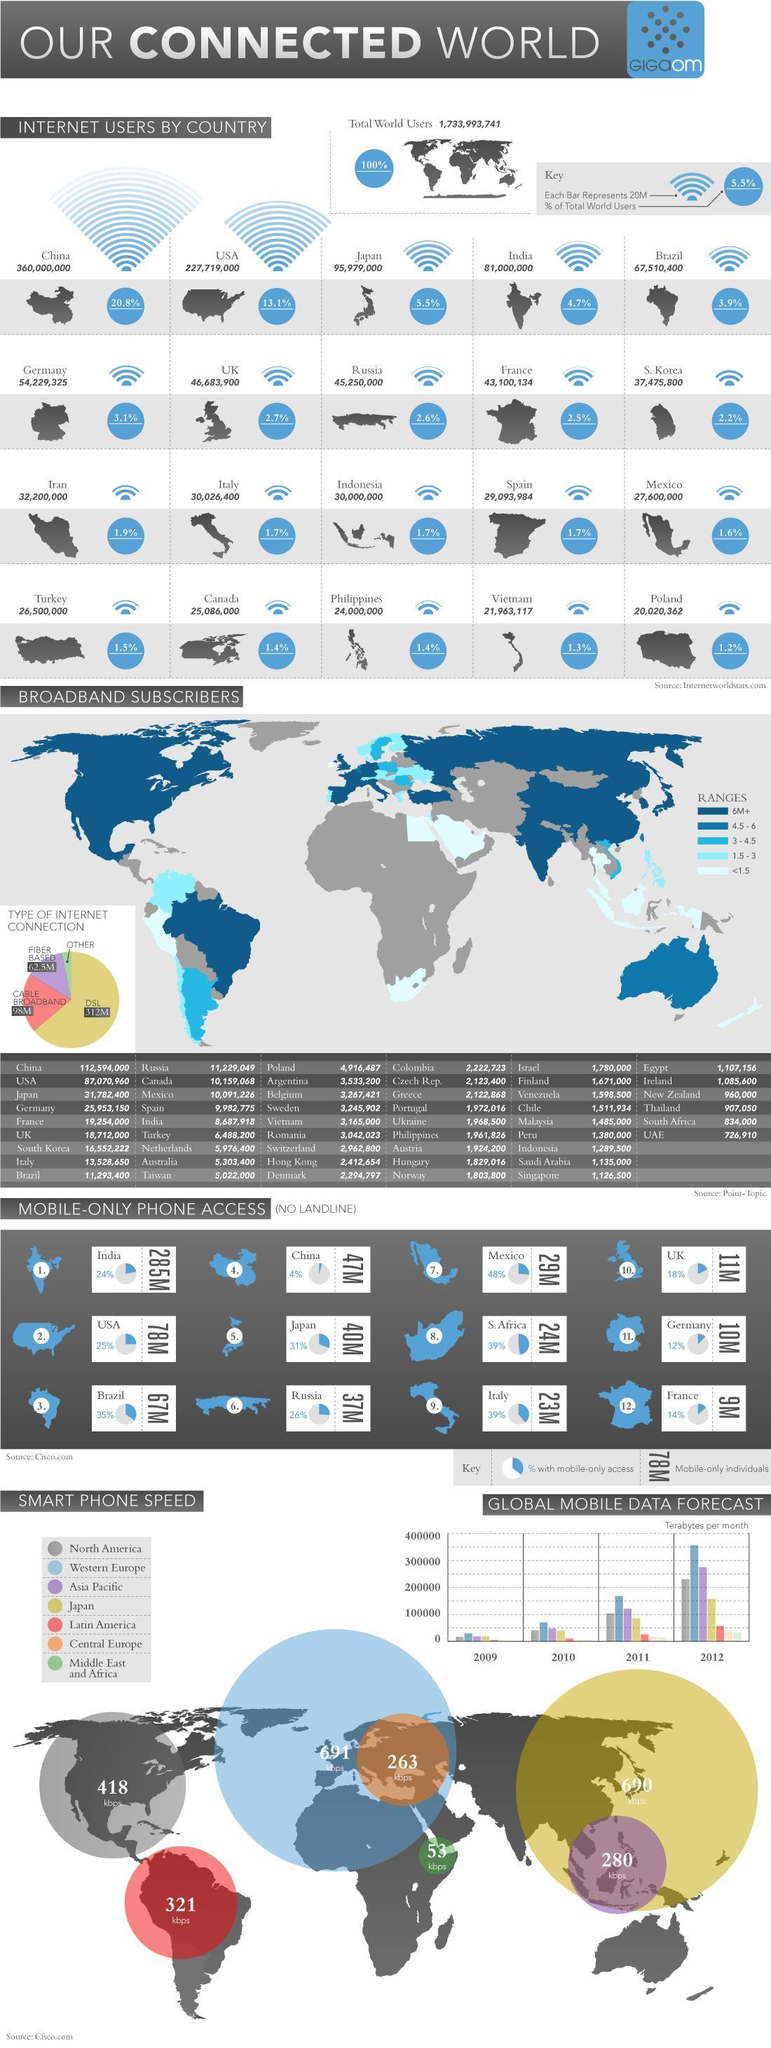What is the smart phone speed in Latin America?
Answer the question with a short phrase. 321 kbps What % of total world users are in Japan? 5.5% Which country has the fourth highest percentage of total world users? India Which country has the third largest number of people who access internet through their mobile phones only? Brazil How much percentage does USA and Canada constitute in total world users ? 14.5% Which country has the second highest smart phone speed? Japan What type of internet connection is used second most in the world? Cable Broadband What is the smart phone speed in Asia Pacific? 280 kbps 